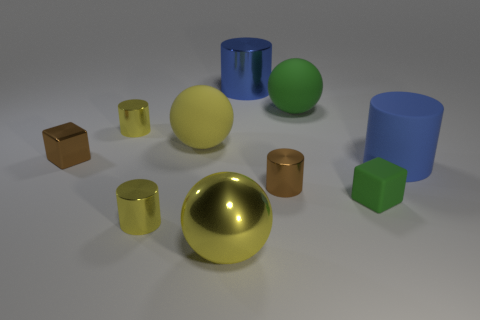How many things are blue metallic cylinders that are behind the big yellow metal thing or big things behind the big yellow shiny sphere?
Your response must be concise. 4. There is a brown cube that is the same size as the green rubber block; what is it made of?
Offer a very short reply. Metal. What number of other things are the same material as the brown cylinder?
Your answer should be very brief. 5. Is the shape of the large rubber thing to the right of the big green matte ball the same as the big metal thing in front of the brown cylinder?
Your response must be concise. No. There is a tiny metallic object to the left of the tiny yellow metal cylinder behind the big matte thing that is on the left side of the blue metal thing; what color is it?
Keep it short and to the point. Brown. What number of other objects are the same color as the tiny matte thing?
Offer a terse response. 1. Are there fewer tiny purple matte cylinders than tiny matte objects?
Ensure brevity in your answer.  Yes. There is a object that is left of the big metal ball and in front of the tiny green matte object; what is its color?
Ensure brevity in your answer.  Yellow. There is a large green object that is the same shape as the yellow matte object; what is it made of?
Give a very brief answer. Rubber. Are there more red matte spheres than cylinders?
Your response must be concise. No. 